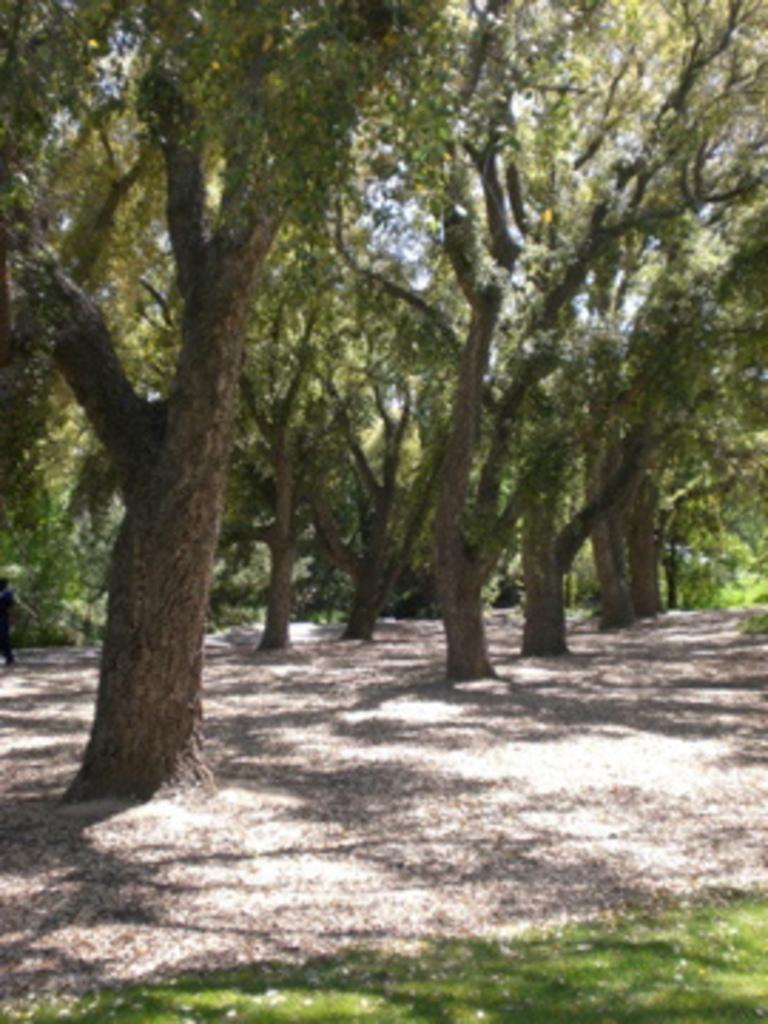What type of vegetation is in the center of the image? There are trees in the center of the image. What type of ground cover is visible at the bottom of the image? There is grass at the bottom of the image. Where are the scissors located in the image? There are no scissors present in the image. What type of vehicle can be seen traveling through the grass in the image? There is no vehicle, such as a train, present in the image. 